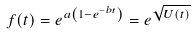<formula> <loc_0><loc_0><loc_500><loc_500>f ( t ) = e ^ { { a } \left ( 1 - e ^ { - b t } \right ) } = e ^ { \sqrt { U ( t ) } }</formula> 